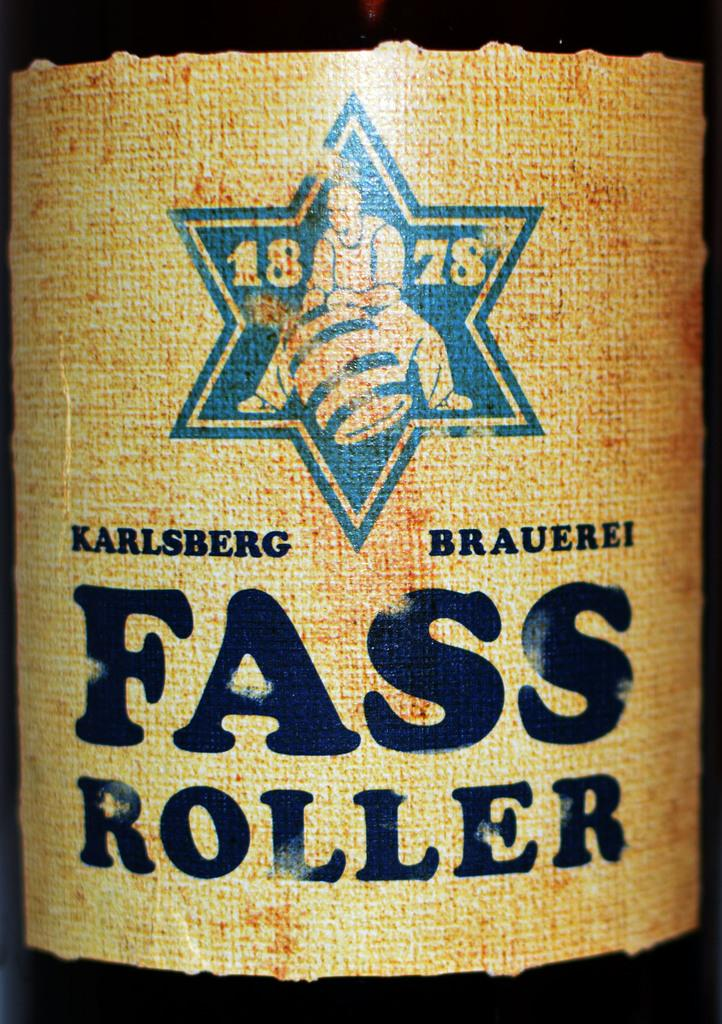Provide a one-sentence caption for the provided image. A close up of the label of a botle of 1878 Karlsberg Fass Roller. 